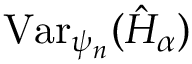<formula> <loc_0><loc_0><loc_500><loc_500>V a r _ { \psi _ { n } } ( \hat { H } _ { \alpha } )</formula> 